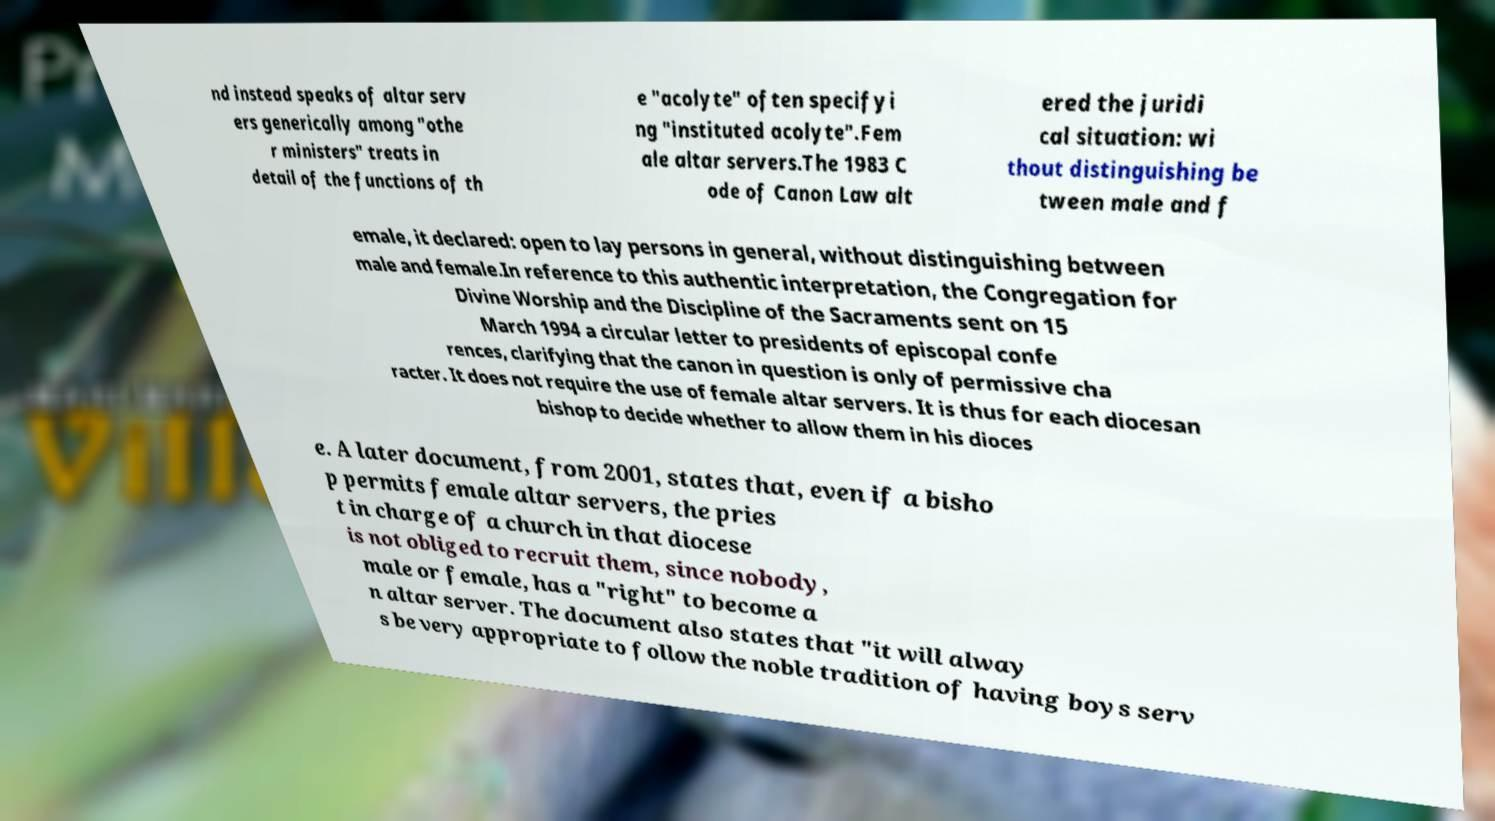Can you read and provide the text displayed in the image?This photo seems to have some interesting text. Can you extract and type it out for me? nd instead speaks of altar serv ers generically among "othe r ministers" treats in detail of the functions of th e "acolyte" often specifyi ng "instituted acolyte".Fem ale altar servers.The 1983 C ode of Canon Law alt ered the juridi cal situation: wi thout distinguishing be tween male and f emale, it declared: open to lay persons in general, without distinguishing between male and female.In reference to this authentic interpretation, the Congregation for Divine Worship and the Discipline of the Sacraments sent on 15 March 1994 a circular letter to presidents of episcopal confe rences, clarifying that the canon in question is only of permissive cha racter. It does not require the use of female altar servers. It is thus for each diocesan bishop to decide whether to allow them in his dioces e. A later document, from 2001, states that, even if a bisho p permits female altar servers, the pries t in charge of a church in that diocese is not obliged to recruit them, since nobody, male or female, has a "right" to become a n altar server. The document also states that "it will alway s be very appropriate to follow the noble tradition of having boys serv 